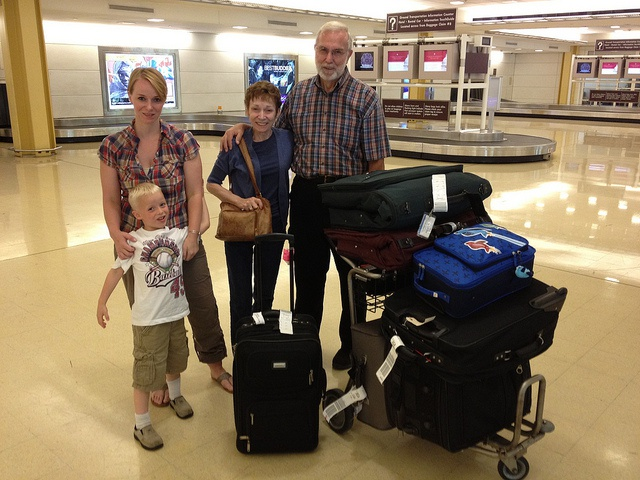Describe the objects in this image and their specific colors. I can see people in brown, black, gray, and maroon tones, people in brown, black, and maroon tones, suitcase in brown, black, khaki, beige, and olive tones, people in brown, olive, gray, darkgray, and tan tones, and people in brown, black, gray, and maroon tones in this image. 